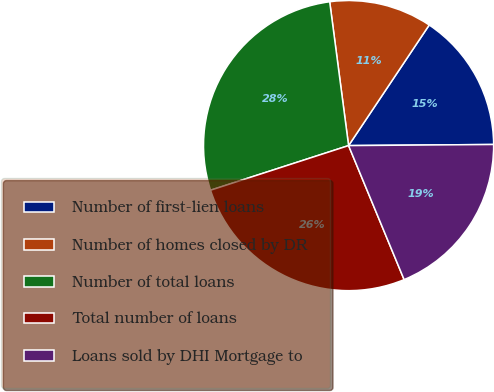Convert chart to OTSL. <chart><loc_0><loc_0><loc_500><loc_500><pie_chart><fcel>Number of first-lien loans<fcel>Number of homes closed by DR<fcel>Number of total loans<fcel>Total number of loans<fcel>Loans sold by DHI Mortgage to<nl><fcel>15.5%<fcel>11.46%<fcel>27.9%<fcel>26.28%<fcel>18.87%<nl></chart> 